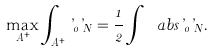<formula> <loc_0><loc_0><loc_500><loc_500>\max _ { A ^ { + } } \int _ { A ^ { + } } \varphi _ { 0 } \varphi _ { N } = \frac { 1 } { 2 } \int _ { \mathbb { R } } \ a b s { \varphi _ { 0 } \varphi _ { N } } .</formula> 